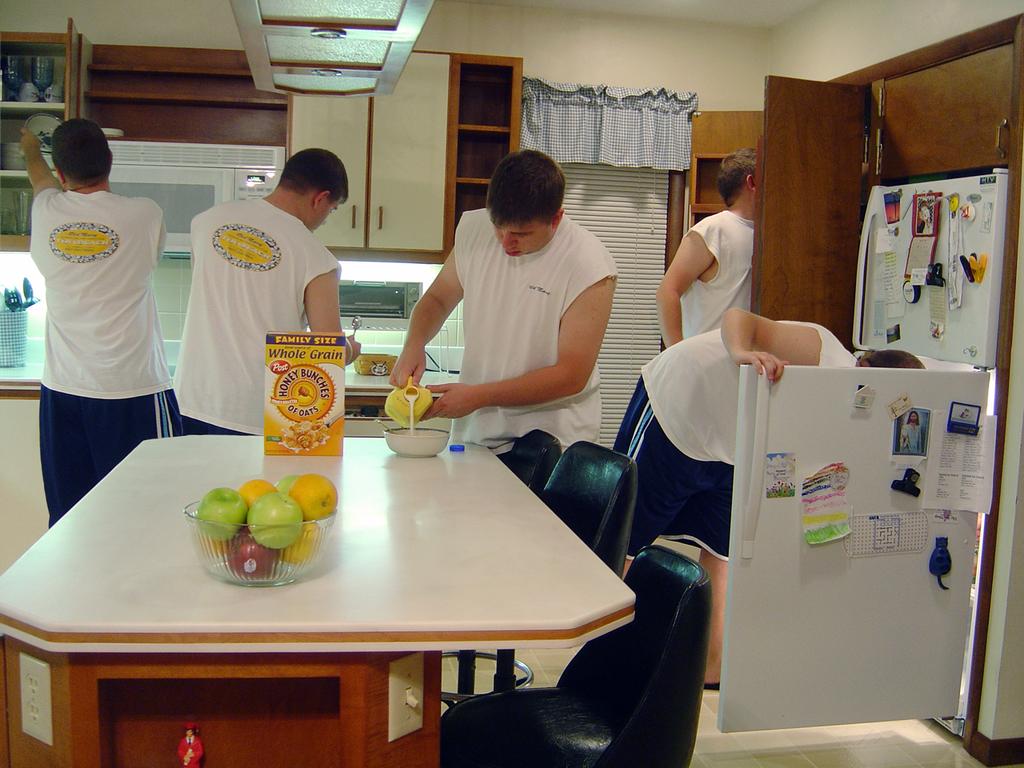What kind of cereal is on the table?
Ensure brevity in your answer.  Honey bunches of oats. 